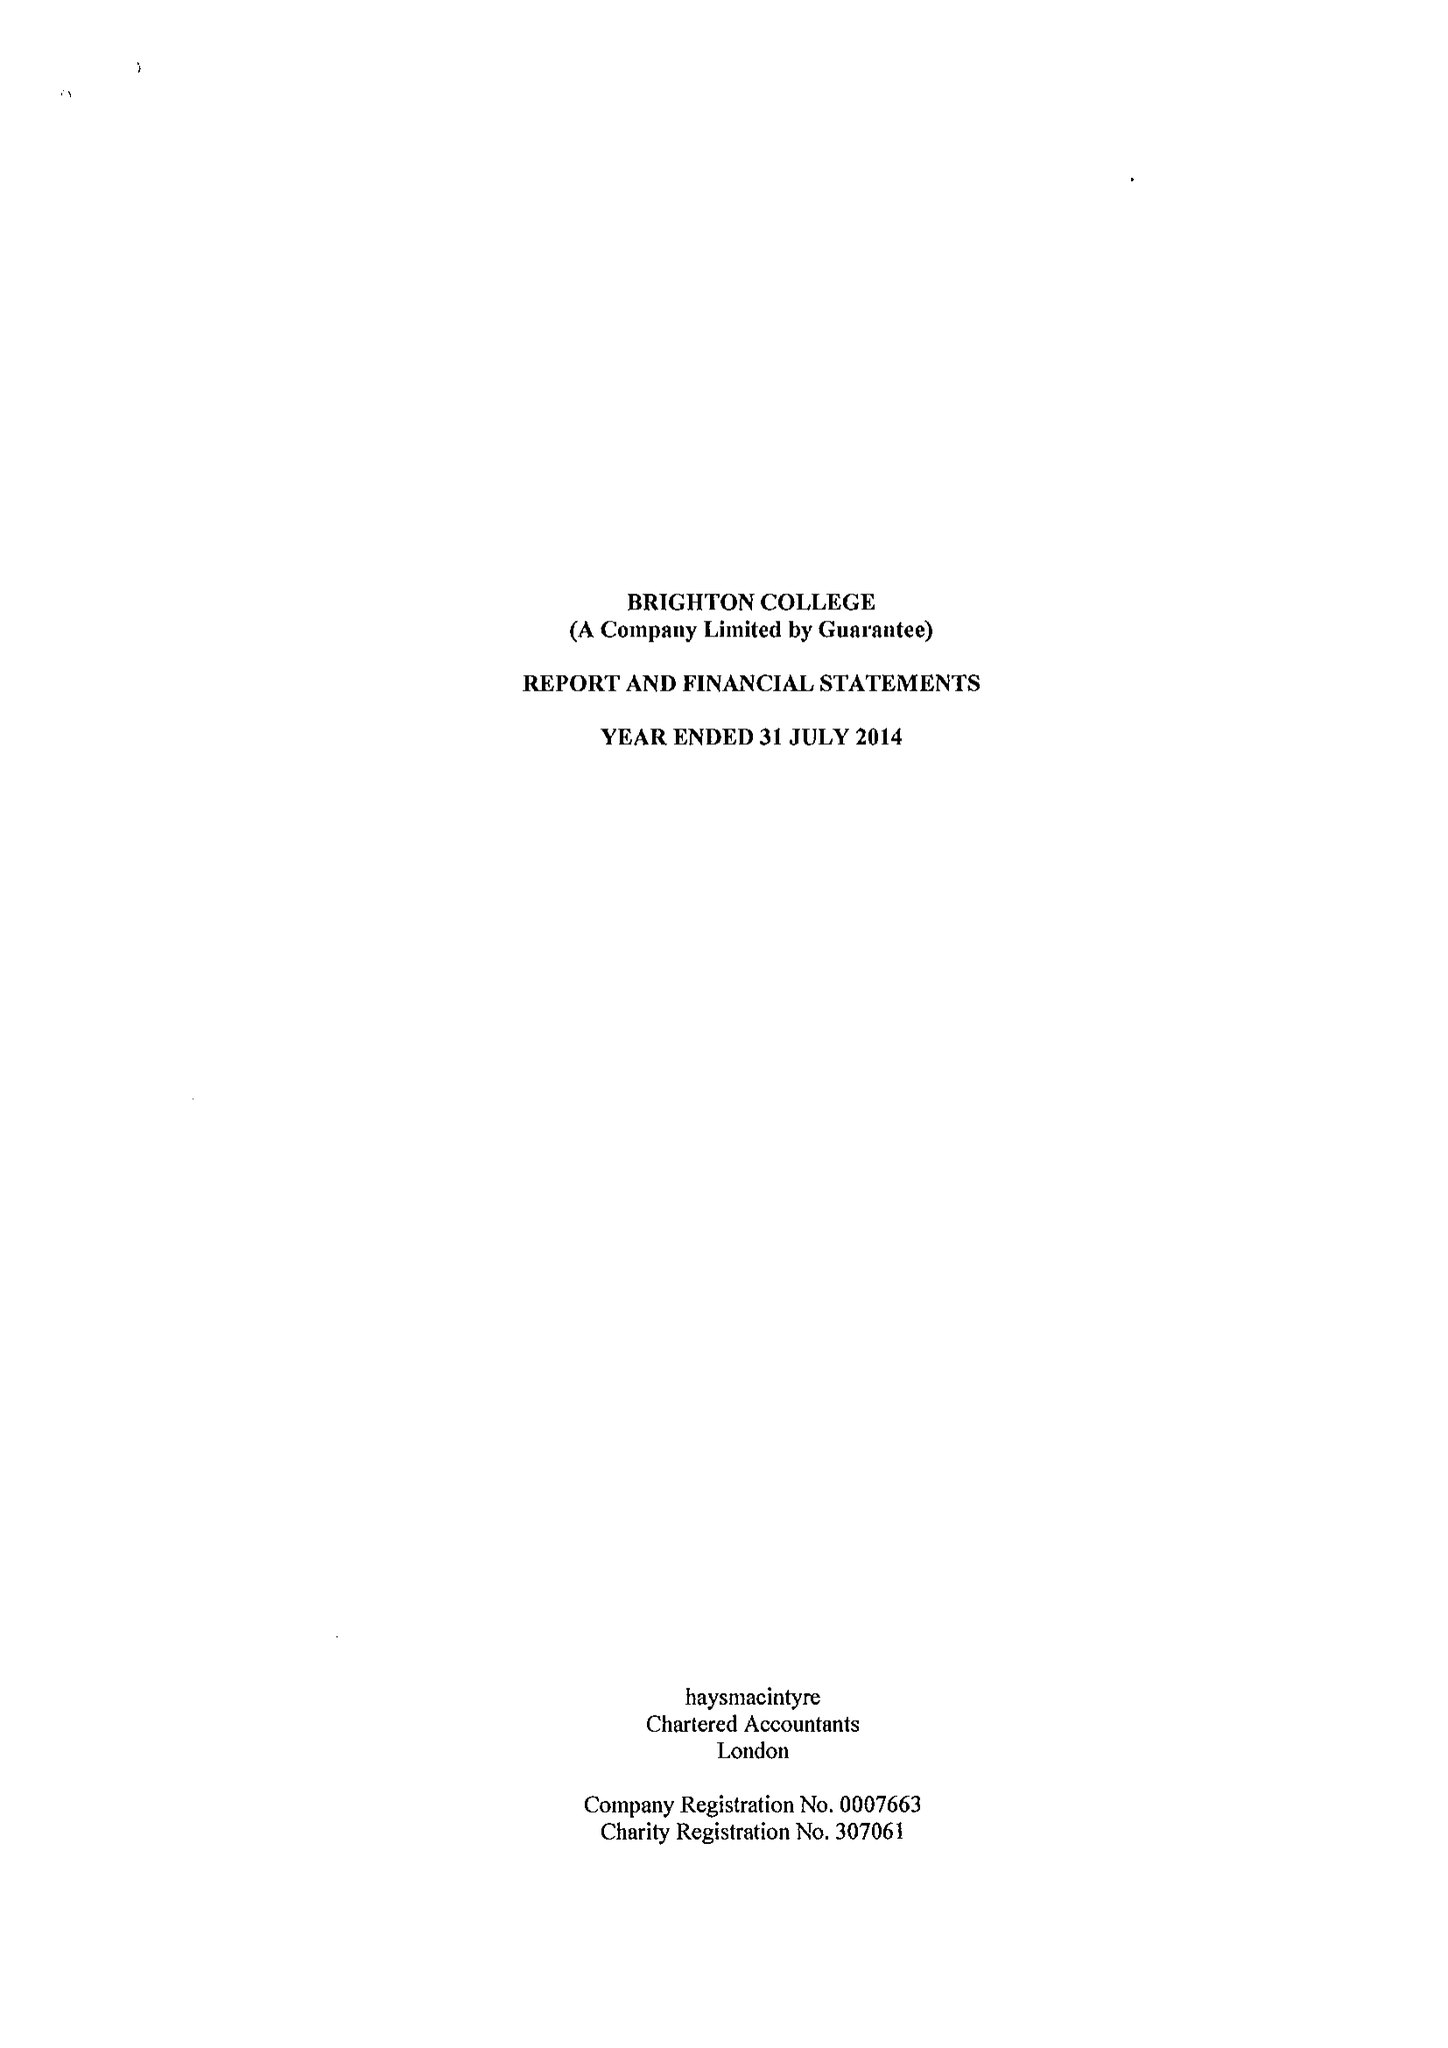What is the value for the spending_annually_in_british_pounds?
Answer the question using a single word or phrase. 31250451.00 